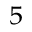Convert formula to latex. <formula><loc_0><loc_0><loc_500><loc_500>^ { 5 }</formula> 